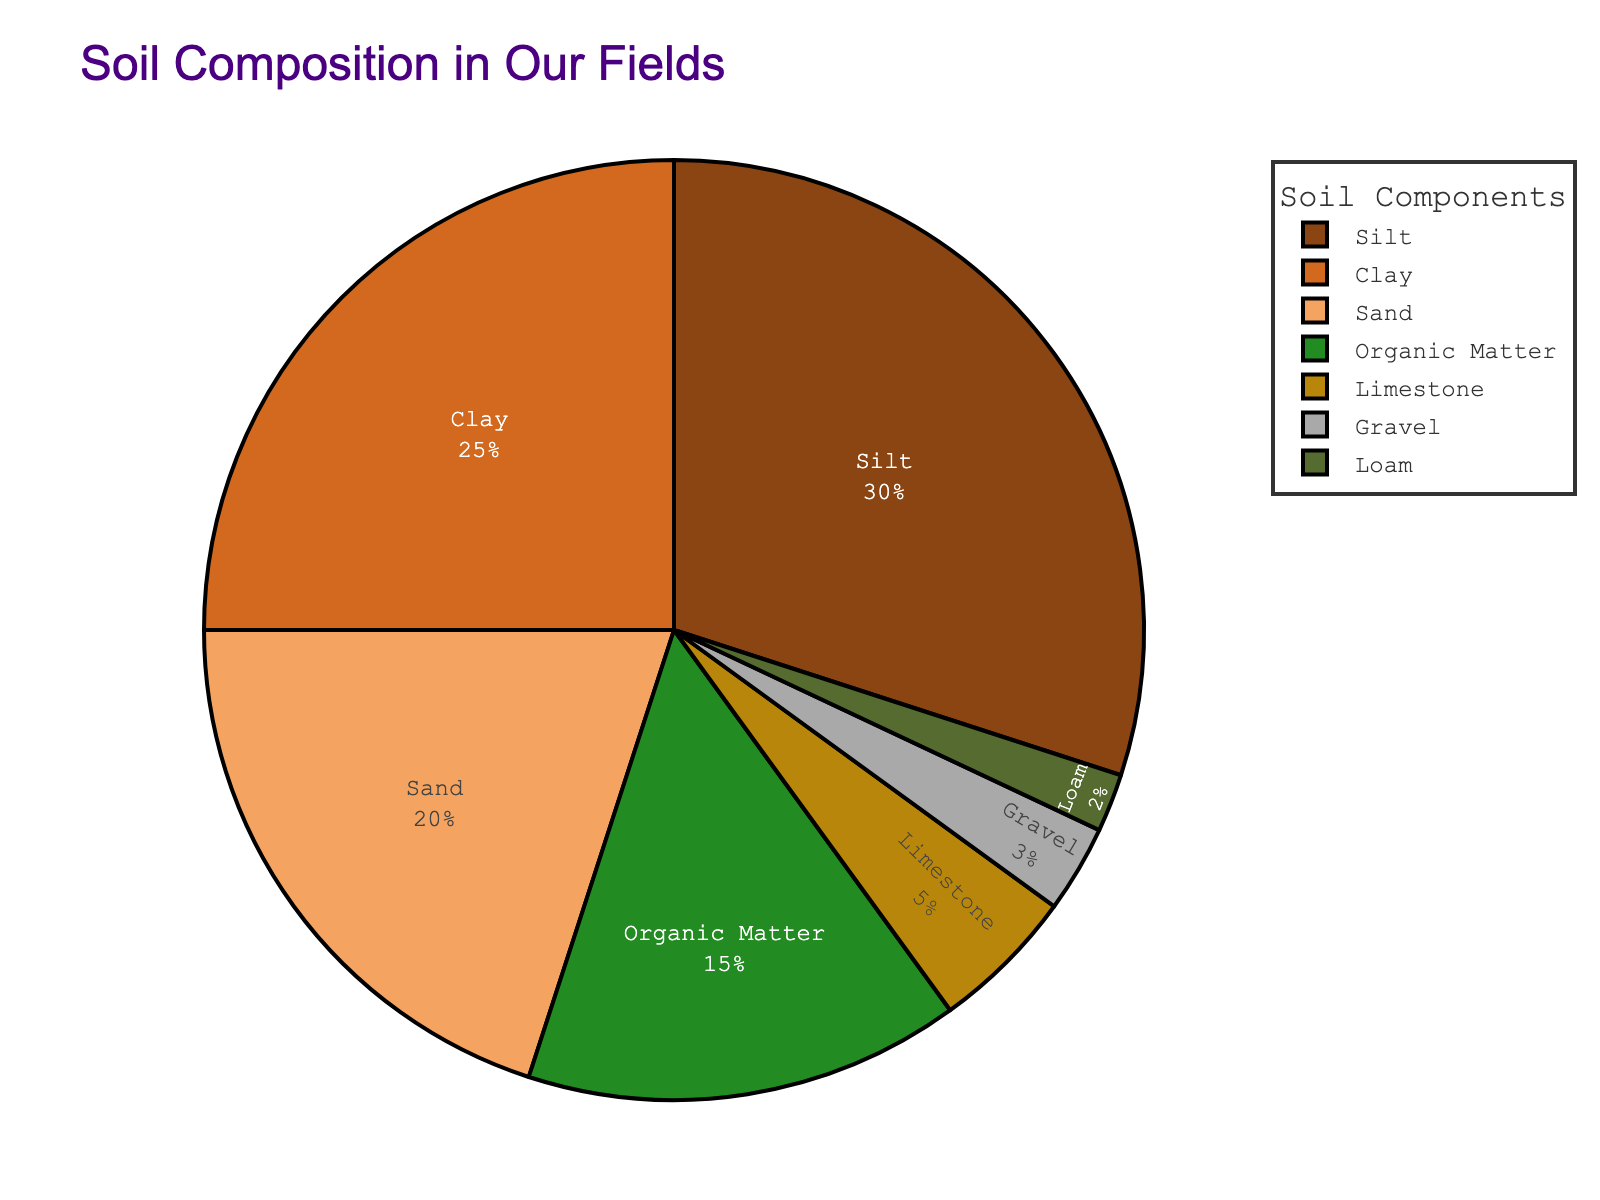What's the percentage of fields composed of organic matter and limestone combined? To find the total percentage of fields composed of organic matter and limestone, sum the percentages of both: Organic Matter (15%) + Limestone (5%) = 20%.
Answer: 20% Which field has the highest composition percentage, and what is its value? By looking at the pie chart, identify the field with the largest slice and note its percentage. Silt has the highest composition at 30%.
Answer: Silt, 30% How much more percentage does clay have compared to sand? Subtract the percentage of sand from the percentage of clay: Clay (25%) - Sand (20%) = 5%.
Answer: 5% Rank the fields by their composition percentage from highest to lowest. List the fields in descending order of their percentages: Silt (30%), Clay (25%), Sand (20%), Organic Matter (15%), Limestone (5%), Gravel (3%), Loam (2%).
Answer: Silt, Clay, Sand, Organic Matter, Limestone, Gravel, Loam What is the combined percentage of all the fields excluding silt? Sum the percentages of all fields except Silt: Clay (25%) + Sand (20%) + Organic Matter (15%) + Limestone (5%) + Gravel (3%) + Loam (2%) = 70%.
Answer: 70% Which two fields have the smallest composition percentages and what are they? Identify the two fields with the smallest slices in the pie chart and note their percentages. Gravel (3%) and Loam (2%) are the smallest.
Answer: Gravel and Loam What is the average percentage of clay, silt, and sand? Sum the percentages of Clay, Silt, and Sand, then divide by 3: (Clay 25% + Silt 30% + Sand 20%) / 3 = 75% / 3 = 25%.
Answer: 25% How does the composition percentage of organic matter compare to sand? Organic Matter (15%) is less than Sand (20%).
Answer: Organic Matter is less than Sand Which field has a composition percentage greater than 10% but less than 20%? Look for the field whose percentage falls between 10% and 20%: Organic Matter fits this criterion with 15%.
Answer: Organic Matter Based on the pie chart, which field is represented by the color green? Identify the segment colored green in the pie chart. The color green represents Organic Matter.
Answer: Organic Matter 